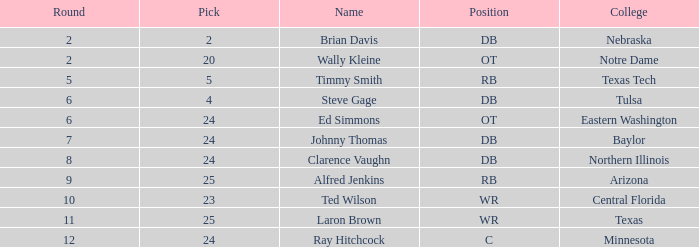What top round has a pick smaller than 2? None. 